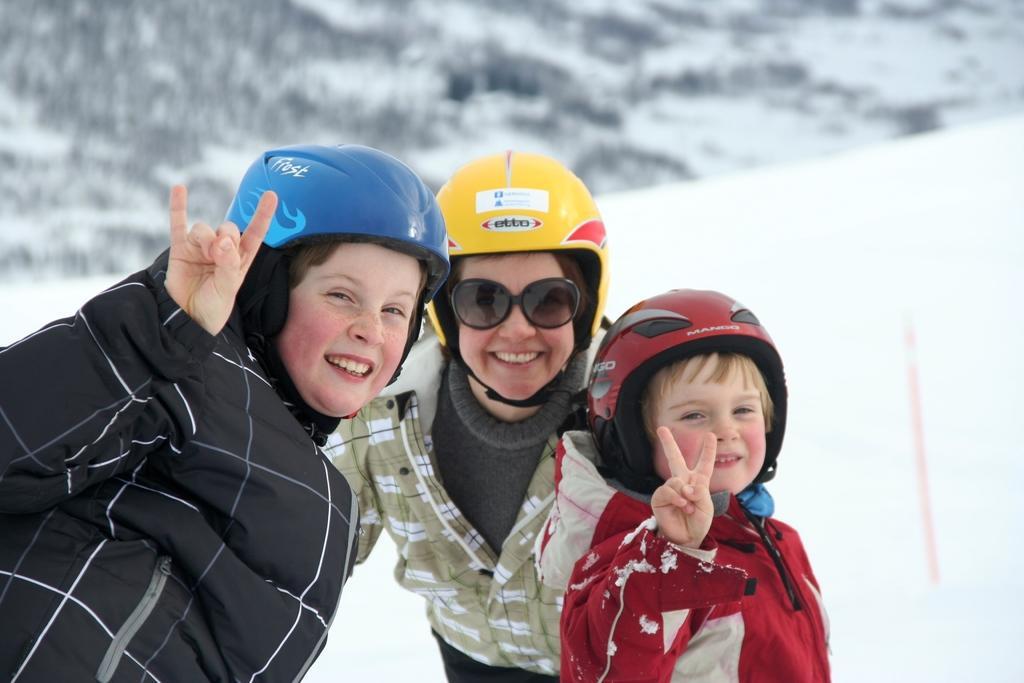How would you summarize this image in a sentence or two? In this image I can see three persons wearing black, green and red colored dresses and blue, yellow and red colored helmets are standing and smiling. In the background I can see the snow. 